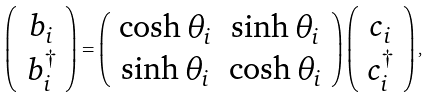Convert formula to latex. <formula><loc_0><loc_0><loc_500><loc_500>\left ( \begin{array} { c c } b _ { i } \\ b _ { i } ^ { \dagger } \end{array} \right ) = \left ( \begin{array} { c c } \cosh \theta _ { i } & \sinh \theta _ { i } \\ \sinh \theta _ { i } & \cosh \theta _ { i } \end{array} \right ) \left ( \begin{array} { c c } c _ { i } \\ c _ { i } ^ { \dagger } \end{array} \right ) ,</formula> 